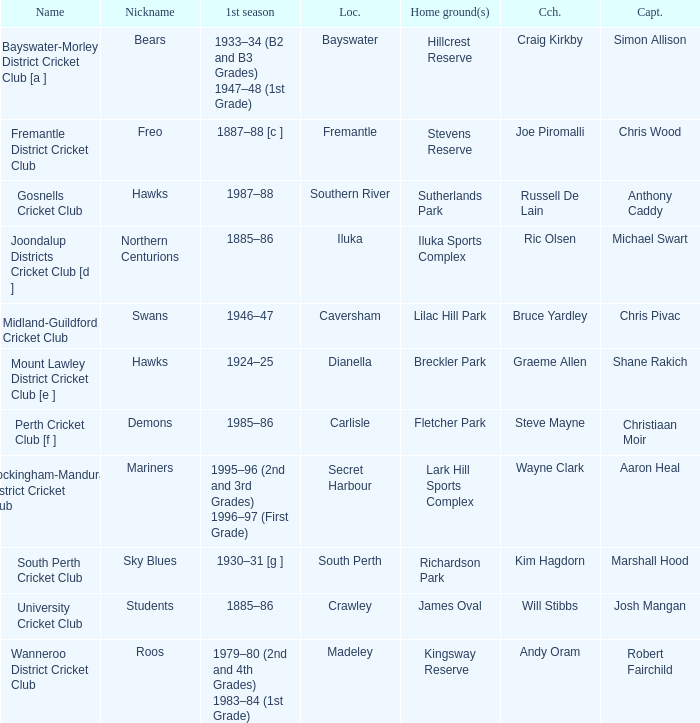What is the code nickname where Steve Mayne is the coach? Demons. 